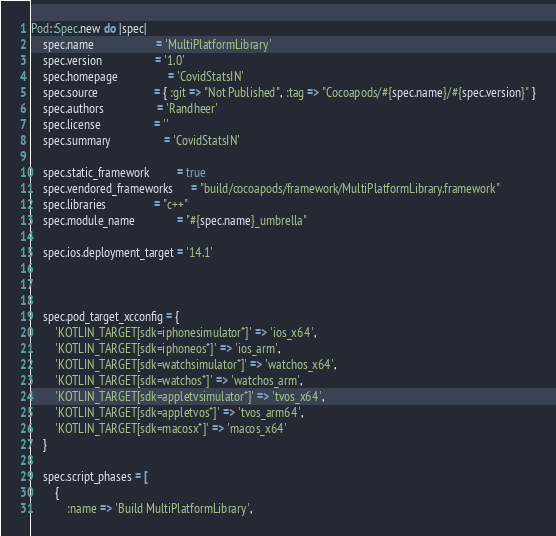<code> <loc_0><loc_0><loc_500><loc_500><_Ruby_>Pod::Spec.new do |spec|
    spec.name                     = 'MultiPlatformLibrary'
    spec.version                  = '1.0'
    spec.homepage                 = 'CovidStatsIN'
    spec.source                   = { :git => "Not Published", :tag => "Cocoapods/#{spec.name}/#{spec.version}" }
    spec.authors                  = 'Randheer'
    spec.license                  = ''
    spec.summary                  = 'CovidStatsIN'

    spec.static_framework         = true
    spec.vendored_frameworks      = "build/cocoapods/framework/MultiPlatformLibrary.framework"
    spec.libraries                = "c++"
    spec.module_name              = "#{spec.name}_umbrella"

    spec.ios.deployment_target = '14.1'

                

    spec.pod_target_xcconfig = {
        'KOTLIN_TARGET[sdk=iphonesimulator*]' => 'ios_x64',
        'KOTLIN_TARGET[sdk=iphoneos*]' => 'ios_arm',
        'KOTLIN_TARGET[sdk=watchsimulator*]' => 'watchos_x64',
        'KOTLIN_TARGET[sdk=watchos*]' => 'watchos_arm',
        'KOTLIN_TARGET[sdk=appletvsimulator*]' => 'tvos_x64',
        'KOTLIN_TARGET[sdk=appletvos*]' => 'tvos_arm64',
        'KOTLIN_TARGET[sdk=macosx*]' => 'macos_x64'
    }

    spec.script_phases = [
        {
            :name => 'Build MultiPlatformLibrary',</code> 